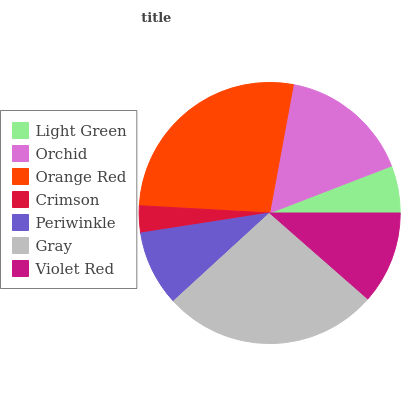Is Crimson the minimum?
Answer yes or no. Yes. Is Orange Red the maximum?
Answer yes or no. Yes. Is Orchid the minimum?
Answer yes or no. No. Is Orchid the maximum?
Answer yes or no. No. Is Orchid greater than Light Green?
Answer yes or no. Yes. Is Light Green less than Orchid?
Answer yes or no. Yes. Is Light Green greater than Orchid?
Answer yes or no. No. Is Orchid less than Light Green?
Answer yes or no. No. Is Violet Red the high median?
Answer yes or no. Yes. Is Violet Red the low median?
Answer yes or no. Yes. Is Light Green the high median?
Answer yes or no. No. Is Light Green the low median?
Answer yes or no. No. 